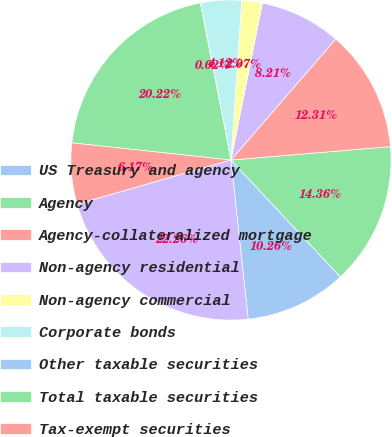Convert chart to OTSL. <chart><loc_0><loc_0><loc_500><loc_500><pie_chart><fcel>US Treasury and agency<fcel>Agency<fcel>Agency-collateralized mortgage<fcel>Non-agency residential<fcel>Non-agency commercial<fcel>Corporate bonds<fcel>Other taxable securities<fcel>Total taxable securities<fcel>Tax-exempt securities<fcel>Total amortized cost of AFS<nl><fcel>10.26%<fcel>14.36%<fcel>12.31%<fcel>8.21%<fcel>2.07%<fcel>4.12%<fcel>0.02%<fcel>20.22%<fcel>6.17%<fcel>22.26%<nl></chart> 